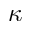<formula> <loc_0><loc_0><loc_500><loc_500>\kappa</formula> 